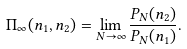Convert formula to latex. <formula><loc_0><loc_0><loc_500><loc_500>\Pi _ { \infty } ( n _ { 1 } , n _ { 2 } ) = \lim _ { N \to \infty } \frac { P _ { N } ( n _ { 2 } ) } { P _ { N } ( n _ { 1 } ) } .</formula> 